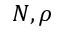Convert formula to latex. <formula><loc_0><loc_0><loc_500><loc_500>N , \rho</formula> 